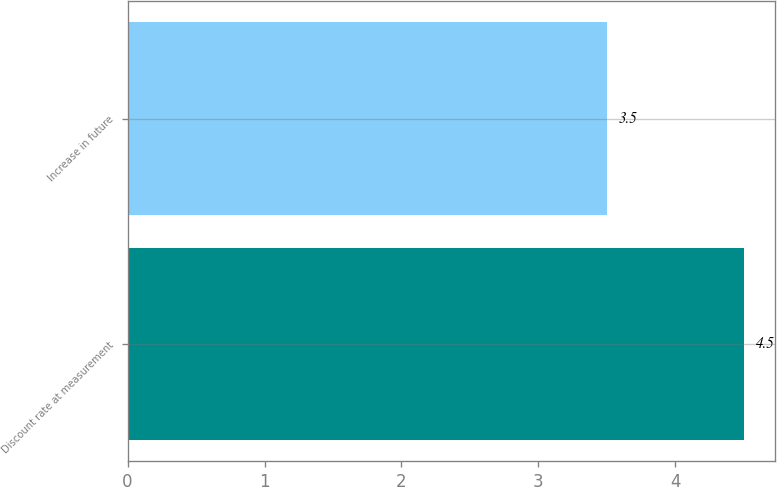<chart> <loc_0><loc_0><loc_500><loc_500><bar_chart><fcel>Discount rate at measurement<fcel>Increase in future<nl><fcel>4.5<fcel>3.5<nl></chart> 